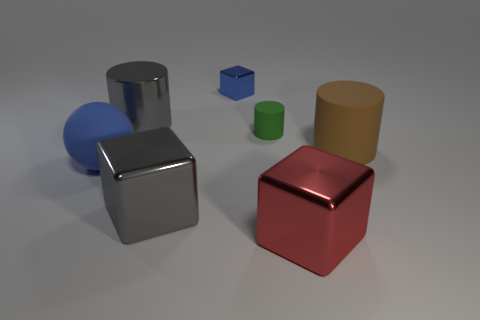Are there any other things that have the same shape as the big blue thing?
Your response must be concise. No. There is a gray object that is behind the small green cylinder; is there a big brown object in front of it?
Keep it short and to the point. Yes. How many matte things are both to the right of the tiny blue metallic object and left of the large gray cylinder?
Give a very brief answer. 0. There is a gray metal object behind the big brown thing; what is its shape?
Keep it short and to the point. Cylinder. How many green matte objects have the same size as the green matte cylinder?
Keep it short and to the point. 0. Is the color of the large rubber object that is to the left of the big red shiny thing the same as the tiny block?
Offer a terse response. Yes. The cylinder that is in front of the gray metallic cylinder and left of the large matte cylinder is made of what material?
Give a very brief answer. Rubber. Are there more small objects than small red spheres?
Your answer should be compact. Yes. There is a large cylinder behind the big matte object right of the metallic object right of the blue metal cube; what color is it?
Your answer should be compact. Gray. Is the material of the large gray thing that is in front of the green rubber thing the same as the large red cube?
Offer a very short reply. Yes. 